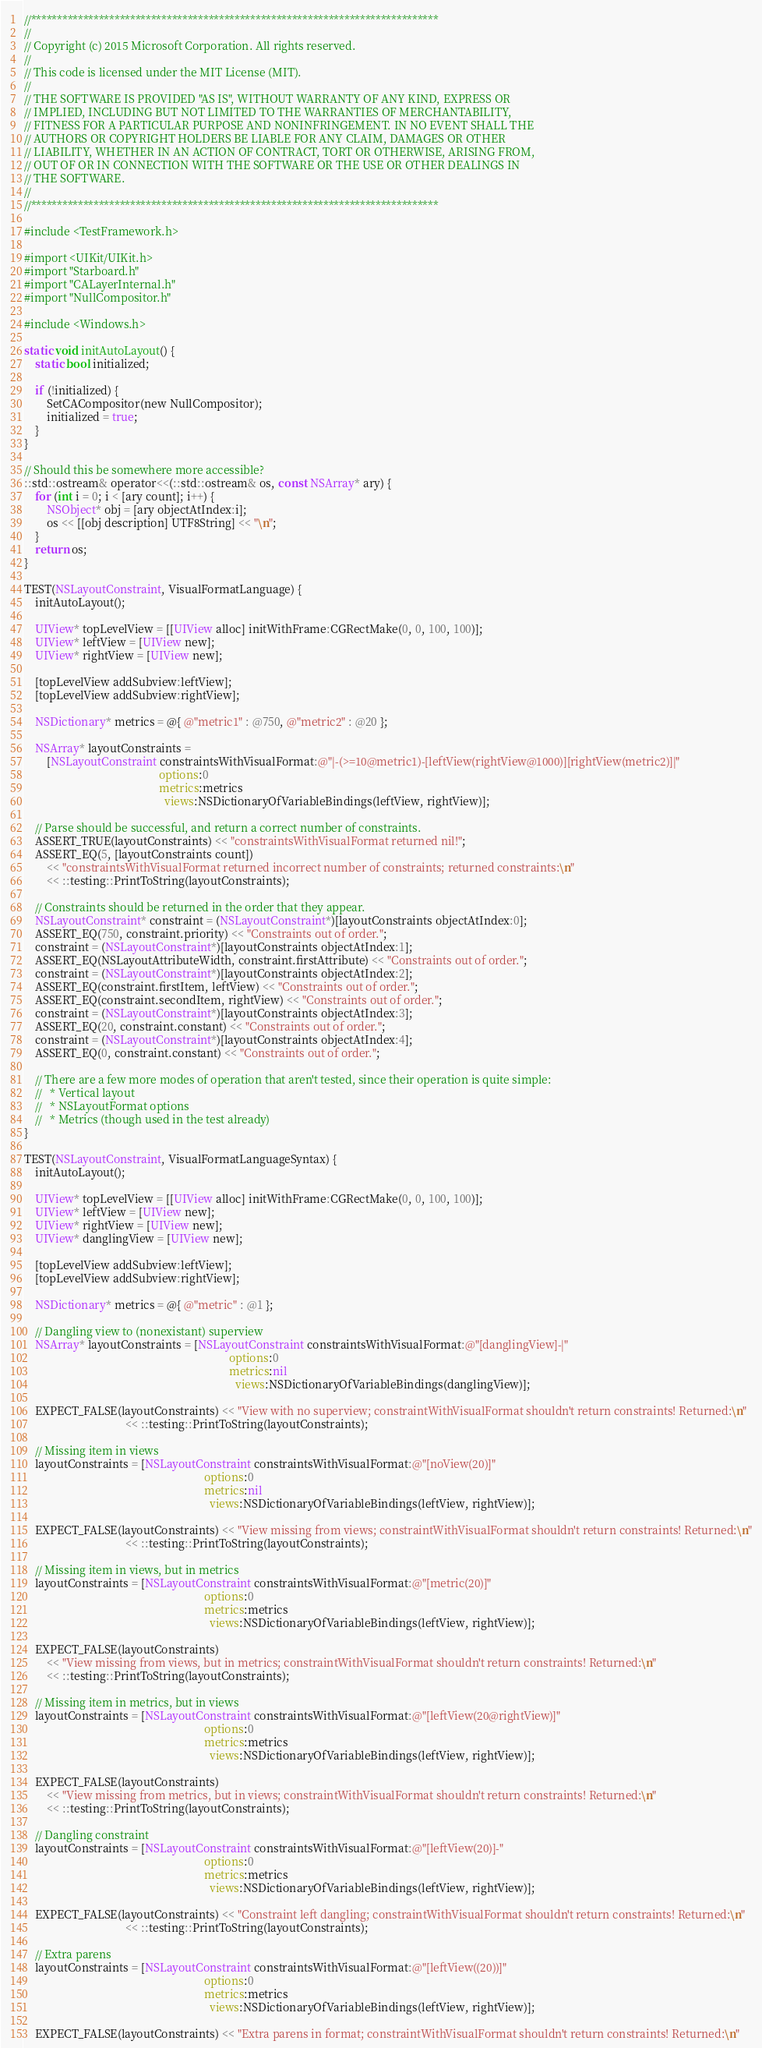<code> <loc_0><loc_0><loc_500><loc_500><_ObjectiveC_>//******************************************************************************
//
// Copyright (c) 2015 Microsoft Corporation. All rights reserved.
//
// This code is licensed under the MIT License (MIT).
//
// THE SOFTWARE IS PROVIDED "AS IS", WITHOUT WARRANTY OF ANY KIND, EXPRESS OR
// IMPLIED, INCLUDING BUT NOT LIMITED TO THE WARRANTIES OF MERCHANTABILITY,
// FITNESS FOR A PARTICULAR PURPOSE AND NONINFRINGEMENT. IN NO EVENT SHALL THE
// AUTHORS OR COPYRIGHT HOLDERS BE LIABLE FOR ANY CLAIM, DAMAGES OR OTHER
// LIABILITY, WHETHER IN AN ACTION OF CONTRACT, TORT OR OTHERWISE, ARISING FROM,
// OUT OF OR IN CONNECTION WITH THE SOFTWARE OR THE USE OR OTHER DEALINGS IN
// THE SOFTWARE.
//
//******************************************************************************

#include <TestFramework.h>

#import <UIKit/UIKit.h>
#import "Starboard.h"
#import "CALayerInternal.h"
#import "NullCompositor.h"

#include <Windows.h>

static void initAutoLayout() {
    static bool initialized;

    if (!initialized) {
        SetCACompositor(new NullCompositor);
        initialized = true;
    }
}

// Should this be somewhere more accessible?
::std::ostream& operator<<(::std::ostream& os, const NSArray* ary) {
    for (int i = 0; i < [ary count]; i++) {
        NSObject* obj = [ary objectAtIndex:i];
        os << [[obj description] UTF8String] << "\n";
    }
    return os;
}

TEST(NSLayoutConstraint, VisualFormatLanguage) {
    initAutoLayout();

    UIView* topLevelView = [[UIView alloc] initWithFrame:CGRectMake(0, 0, 100, 100)];
    UIView* leftView = [UIView new];
    UIView* rightView = [UIView new];

    [topLevelView addSubview:leftView];
    [topLevelView addSubview:rightView];

    NSDictionary* metrics = @{ @"metric1" : @750, @"metric2" : @20 };

    NSArray* layoutConstraints =
        [NSLayoutConstraint constraintsWithVisualFormat:@"|-(>=10@metric1)-[leftView(rightView@1000)][rightView(metric2)]|"
                                                options:0
                                                metrics:metrics
                                                  views:NSDictionaryOfVariableBindings(leftView, rightView)];

    // Parse should be successful, and return a correct number of constraints.
    ASSERT_TRUE(layoutConstraints) << "constraintsWithVisualFormat returned nil!";
    ASSERT_EQ(5, [layoutConstraints count])
        << "constraintsWithVisualFormat returned incorrect number of constraints; returned constraints:\n"
        << ::testing::PrintToString(layoutConstraints);

    // Constraints should be returned in the order that they appear.
    NSLayoutConstraint* constraint = (NSLayoutConstraint*)[layoutConstraints objectAtIndex:0];
    ASSERT_EQ(750, constraint.priority) << "Constraints out of order.";
    constraint = (NSLayoutConstraint*)[layoutConstraints objectAtIndex:1];
    ASSERT_EQ(NSLayoutAttributeWidth, constraint.firstAttribute) << "Constraints out of order.";
    constraint = (NSLayoutConstraint*)[layoutConstraints objectAtIndex:2];
    ASSERT_EQ(constraint.firstItem, leftView) << "Constraints out of order.";
    ASSERT_EQ(constraint.secondItem, rightView) << "Constraints out of order.";
    constraint = (NSLayoutConstraint*)[layoutConstraints objectAtIndex:3];
    ASSERT_EQ(20, constraint.constant) << "Constraints out of order.";
    constraint = (NSLayoutConstraint*)[layoutConstraints objectAtIndex:4];
    ASSERT_EQ(0, constraint.constant) << "Constraints out of order.";

    // There are a few more modes of operation that aren't tested, since their operation is quite simple:
    //   * Vertical layout
    //   * NSLayoutFormat options
    //   * Metrics (though used in the test already)
}

TEST(NSLayoutConstraint, VisualFormatLanguageSyntax) {
    initAutoLayout();

    UIView* topLevelView = [[UIView alloc] initWithFrame:CGRectMake(0, 0, 100, 100)];
    UIView* leftView = [UIView new];
    UIView* rightView = [UIView new];
    UIView* danglingView = [UIView new];

    [topLevelView addSubview:leftView];
    [topLevelView addSubview:rightView];

    NSDictionary* metrics = @{ @"metric" : @1 };

    // Dangling view to (nonexistant) superview
    NSArray* layoutConstraints = [NSLayoutConstraint constraintsWithVisualFormat:@"[danglingView]-|"
                                                                         options:0
                                                                         metrics:nil
                                                                           views:NSDictionaryOfVariableBindings(danglingView)];

    EXPECT_FALSE(layoutConstraints) << "View with no superview; constraintWithVisualFormat shouldn't return constraints! Returned:\n"
                                    << ::testing::PrintToString(layoutConstraints);

    // Missing item in views
    layoutConstraints = [NSLayoutConstraint constraintsWithVisualFormat:@"[noView(20)]"
                                                                options:0
                                                                metrics:nil
                                                                  views:NSDictionaryOfVariableBindings(leftView, rightView)];

    EXPECT_FALSE(layoutConstraints) << "View missing from views; constraintWithVisualFormat shouldn't return constraints! Returned:\n"
                                    << ::testing::PrintToString(layoutConstraints);

    // Missing item in views, but in metrics
    layoutConstraints = [NSLayoutConstraint constraintsWithVisualFormat:@"[metric(20)]"
                                                                options:0
                                                                metrics:metrics
                                                                  views:NSDictionaryOfVariableBindings(leftView, rightView)];

    EXPECT_FALSE(layoutConstraints)
        << "View missing from views, but in metrics; constraintWithVisualFormat shouldn't return constraints! Returned:\n"
        << ::testing::PrintToString(layoutConstraints);

    // Missing item in metrics, but in views
    layoutConstraints = [NSLayoutConstraint constraintsWithVisualFormat:@"[leftView(20@rightView)]"
                                                                options:0
                                                                metrics:metrics
                                                                  views:NSDictionaryOfVariableBindings(leftView, rightView)];

    EXPECT_FALSE(layoutConstraints)
        << "View missing from metrics, but in views; constraintWithVisualFormat shouldn't return constraints! Returned:\n"
        << ::testing::PrintToString(layoutConstraints);

    // Dangling constraint
    layoutConstraints = [NSLayoutConstraint constraintsWithVisualFormat:@"[leftView(20)]-"
                                                                options:0
                                                                metrics:metrics
                                                                  views:NSDictionaryOfVariableBindings(leftView, rightView)];

    EXPECT_FALSE(layoutConstraints) << "Constraint left dangling; constraintWithVisualFormat shouldn't return constraints! Returned:\n"
                                    << ::testing::PrintToString(layoutConstraints);

    // Extra parens
    layoutConstraints = [NSLayoutConstraint constraintsWithVisualFormat:@"[leftView((20))]"
                                                                options:0
                                                                metrics:metrics
                                                                  views:NSDictionaryOfVariableBindings(leftView, rightView)];

    EXPECT_FALSE(layoutConstraints) << "Extra parens in format; constraintWithVisualFormat shouldn't return constraints! Returned:\n"</code> 